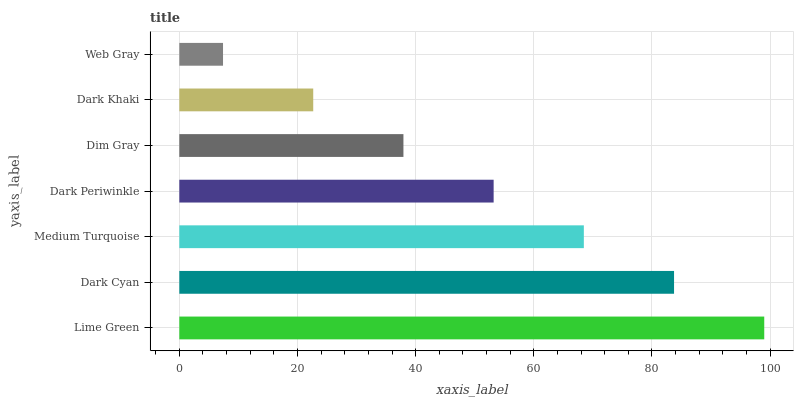Is Web Gray the minimum?
Answer yes or no. Yes. Is Lime Green the maximum?
Answer yes or no. Yes. Is Dark Cyan the minimum?
Answer yes or no. No. Is Dark Cyan the maximum?
Answer yes or no. No. Is Lime Green greater than Dark Cyan?
Answer yes or no. Yes. Is Dark Cyan less than Lime Green?
Answer yes or no. Yes. Is Dark Cyan greater than Lime Green?
Answer yes or no. No. Is Lime Green less than Dark Cyan?
Answer yes or no. No. Is Dark Periwinkle the high median?
Answer yes or no. Yes. Is Dark Periwinkle the low median?
Answer yes or no. Yes. Is Dark Cyan the high median?
Answer yes or no. No. Is Dark Cyan the low median?
Answer yes or no. No. 